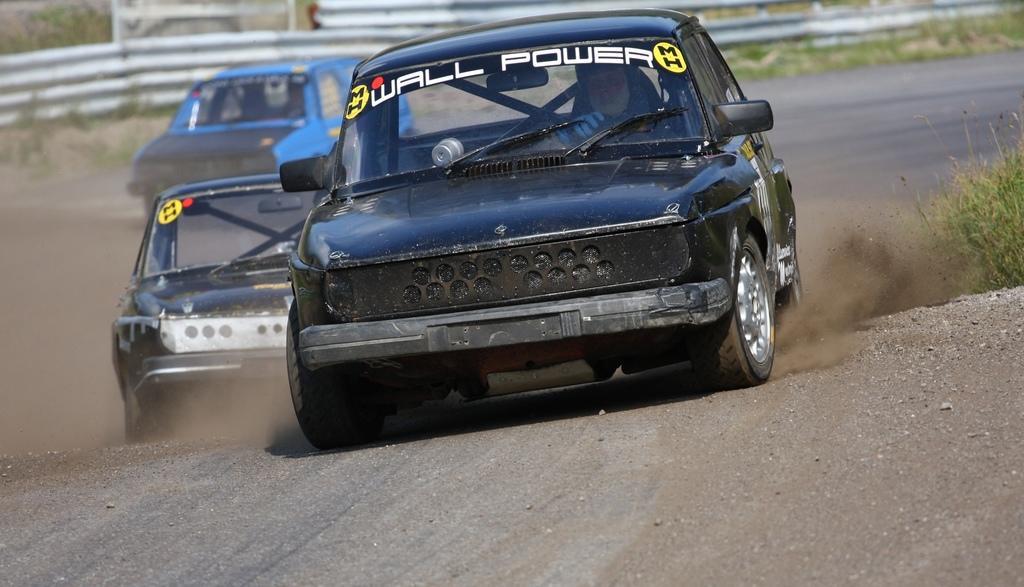How would you summarize this image in a sentence or two? In this picture we can see a man in the car. Behind the car there are two other cars and behind the vehicles there is a fence and plants. 